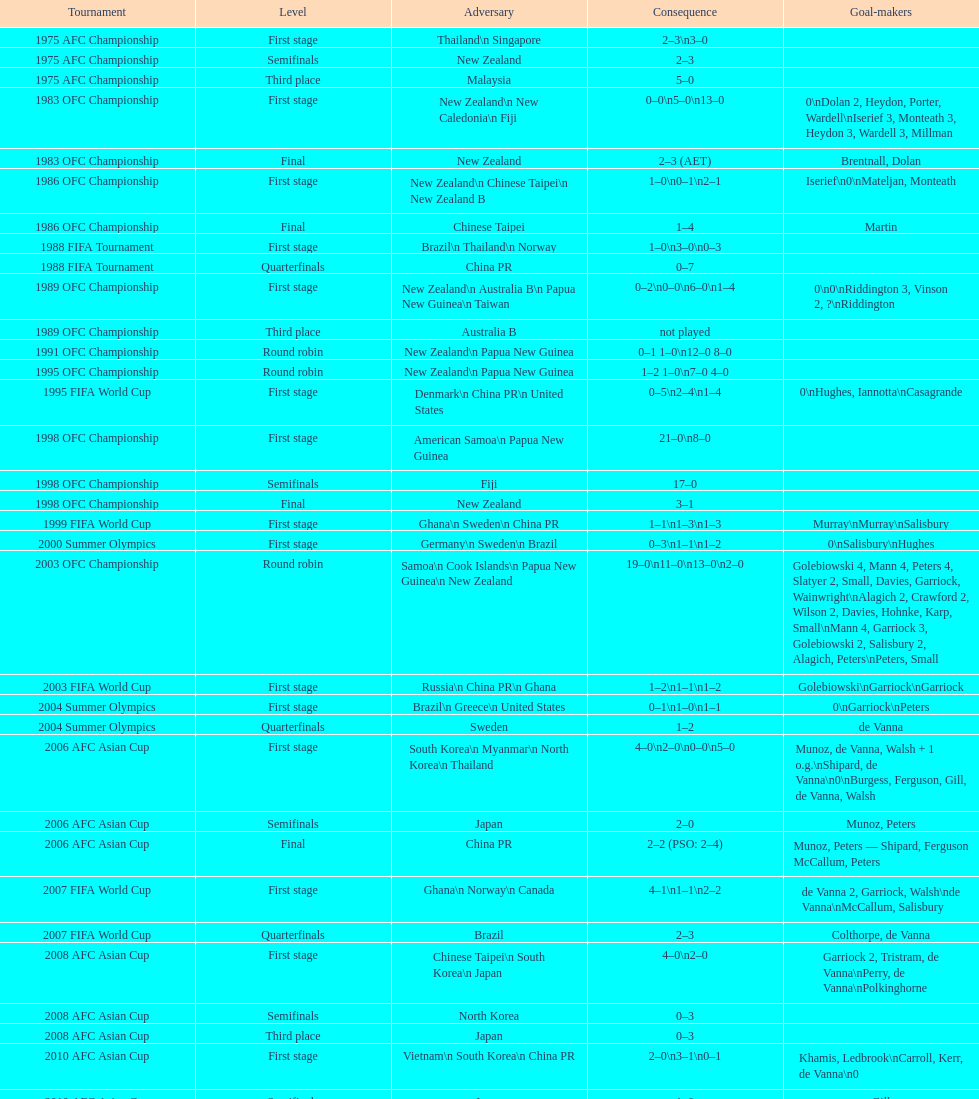What was the total goals made in the 1983 ofc championship? 18. 